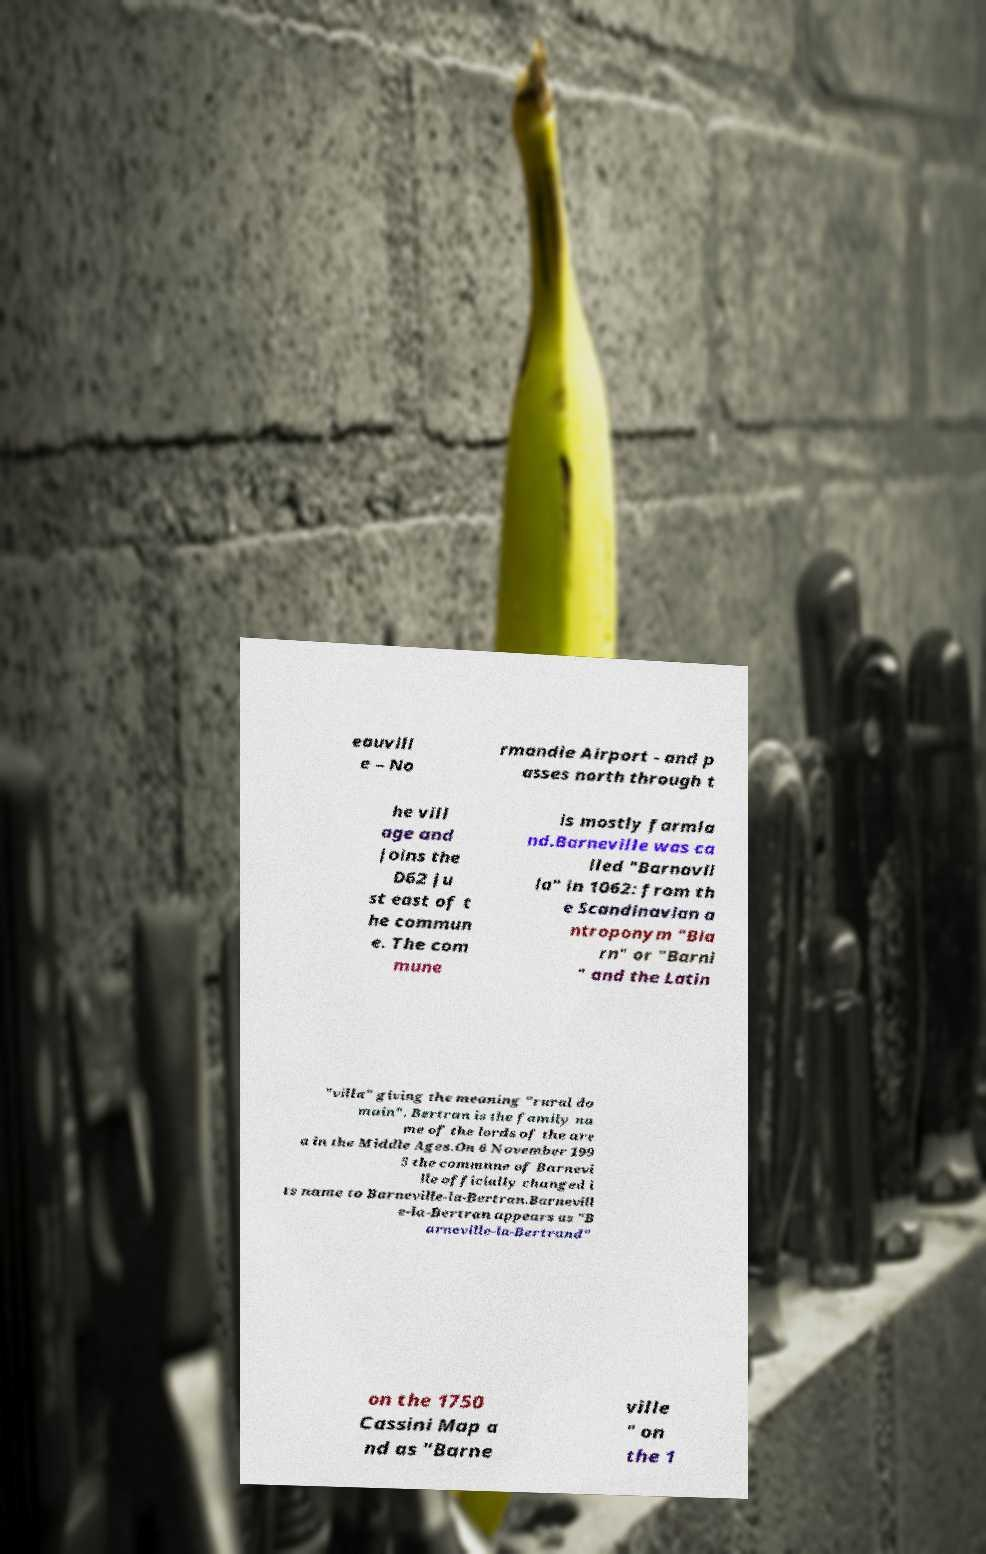Please read and relay the text visible in this image. What does it say? eauvill e – No rmandie Airport - and p asses north through t he vill age and joins the D62 ju st east of t he commun e. The com mune is mostly farmla nd.Barneville was ca lled "Barnavil la" in 1062: from th e Scandinavian a ntroponym "Bia rn" or "Barni " and the Latin "villa" giving the meaning "rural do main". Bertran is the family na me of the lords of the are a in the Middle Ages.On 6 November 199 5 the commune of Barnevi lle officially changed i ts name to Barneville-la-Bertran.Barnevill e-la-Bertran appears as "B arneville-la-Bertrand" on the 1750 Cassini Map a nd as "Barne ville " on the 1 